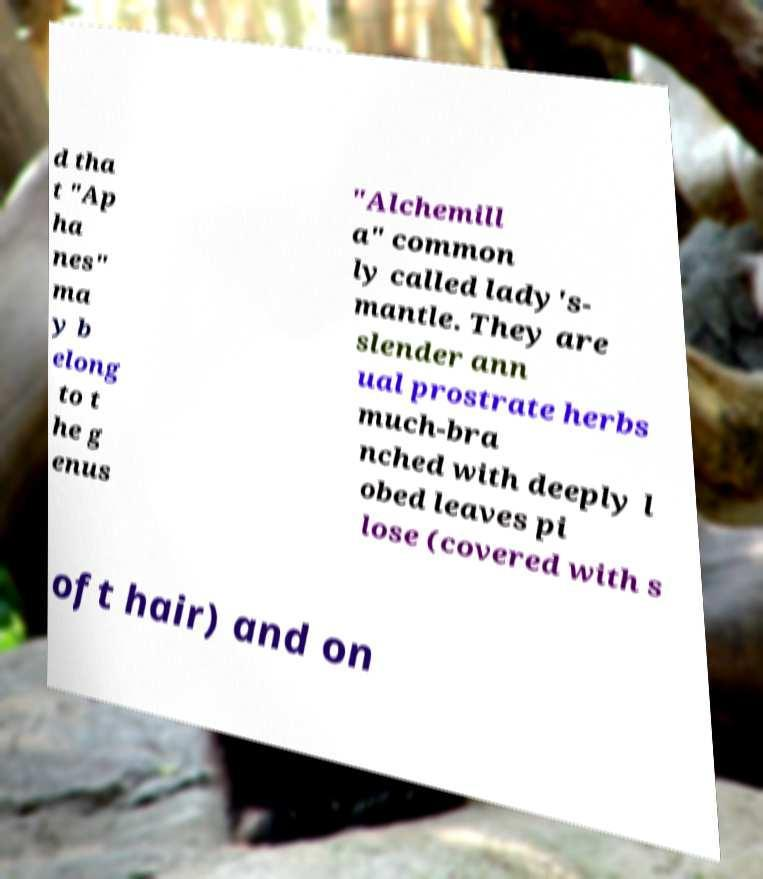What messages or text are displayed in this image? I need them in a readable, typed format. d tha t "Ap ha nes" ma y b elong to t he g enus "Alchemill a" common ly called lady's- mantle. They are slender ann ual prostrate herbs much-bra nched with deeply l obed leaves pi lose (covered with s oft hair) and on 